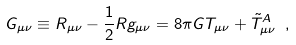Convert formula to latex. <formula><loc_0><loc_0><loc_500><loc_500>G _ { \mu \nu } \equiv R _ { \mu \nu } - \frac { 1 } { 2 } R g _ { \mu \nu } = 8 \pi G T _ { \mu \nu } + \tilde { T } _ { \mu \nu } ^ { A } \ ,</formula> 